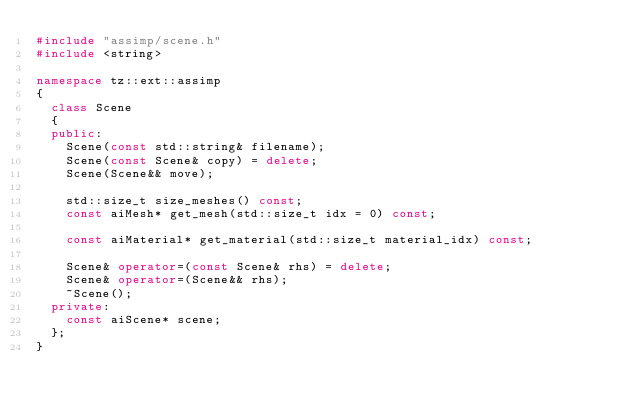Convert code to text. <code><loc_0><loc_0><loc_500><loc_500><_C++_>#include "assimp/scene.h"
#include <string>

namespace tz::ext::assimp
{
	class Scene
	{
	public:
		Scene(const std::string& filename);
		Scene(const Scene& copy) = delete;
		Scene(Scene&& move);

		std::size_t size_meshes() const;
		const aiMesh* get_mesh(std::size_t idx = 0) const;

		const aiMaterial* get_material(std::size_t material_idx) const;

		Scene& operator=(const Scene& rhs) = delete;
		Scene& operator=(Scene&& rhs);
		~Scene();
	private:
		const aiScene* scene;
	};
}</code> 